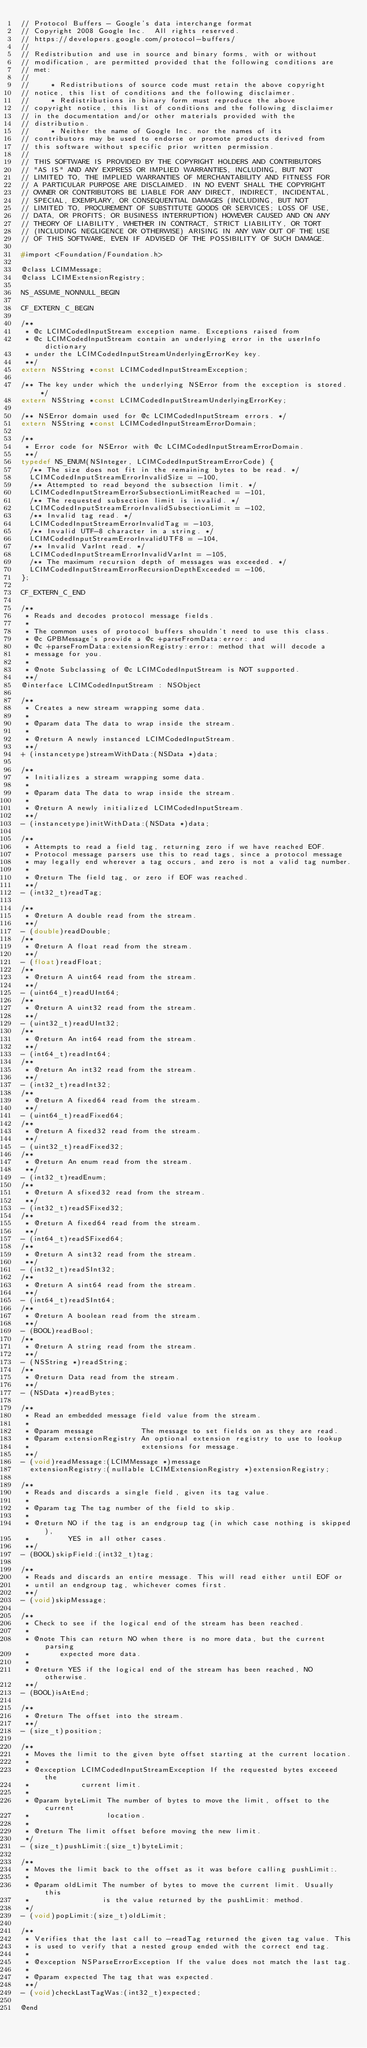<code> <loc_0><loc_0><loc_500><loc_500><_C_>// Protocol Buffers - Google's data interchange format
// Copyright 2008 Google Inc.  All rights reserved.
// https://developers.google.com/protocol-buffers/
//
// Redistribution and use in source and binary forms, with or without
// modification, are permitted provided that the following conditions are
// met:
//
//     * Redistributions of source code must retain the above copyright
// notice, this list of conditions and the following disclaimer.
//     * Redistributions in binary form must reproduce the above
// copyright notice, this list of conditions and the following disclaimer
// in the documentation and/or other materials provided with the
// distribution.
//     * Neither the name of Google Inc. nor the names of its
// contributors may be used to endorse or promote products derived from
// this software without specific prior written permission.
//
// THIS SOFTWARE IS PROVIDED BY THE COPYRIGHT HOLDERS AND CONTRIBUTORS
// "AS IS" AND ANY EXPRESS OR IMPLIED WARRANTIES, INCLUDING, BUT NOT
// LIMITED TO, THE IMPLIED WARRANTIES OF MERCHANTABILITY AND FITNESS FOR
// A PARTICULAR PURPOSE ARE DISCLAIMED. IN NO EVENT SHALL THE COPYRIGHT
// OWNER OR CONTRIBUTORS BE LIABLE FOR ANY DIRECT, INDIRECT, INCIDENTAL,
// SPECIAL, EXEMPLARY, OR CONSEQUENTIAL DAMAGES (INCLUDING, BUT NOT
// LIMITED TO, PROCUREMENT OF SUBSTITUTE GOODS OR SERVICES; LOSS OF USE,
// DATA, OR PROFITS; OR BUSINESS INTERRUPTION) HOWEVER CAUSED AND ON ANY
// THEORY OF LIABILITY, WHETHER IN CONTRACT, STRICT LIABILITY, OR TORT
// (INCLUDING NEGLIGENCE OR OTHERWISE) ARISING IN ANY WAY OUT OF THE USE
// OF THIS SOFTWARE, EVEN IF ADVISED OF THE POSSIBILITY OF SUCH DAMAGE.

#import <Foundation/Foundation.h>

@class LCIMMessage;
@class LCIMExtensionRegistry;

NS_ASSUME_NONNULL_BEGIN

CF_EXTERN_C_BEGIN

/**
 * @c LCIMCodedInputStream exception name. Exceptions raised from
 * @c LCIMCodedInputStream contain an underlying error in the userInfo dictionary
 * under the LCIMCodedInputStreamUnderlyingErrorKey key.
 **/
extern NSString *const LCIMCodedInputStreamException;

/** The key under which the underlying NSError from the exception is stored. */
extern NSString *const LCIMCodedInputStreamUnderlyingErrorKey;

/** NSError domain used for @c LCIMCodedInputStream errors. */
extern NSString *const LCIMCodedInputStreamErrorDomain;

/**
 * Error code for NSError with @c LCIMCodedInputStreamErrorDomain.
 **/
typedef NS_ENUM(NSInteger, LCIMCodedInputStreamErrorCode) {
  /** The size does not fit in the remaining bytes to be read. */
  LCIMCodedInputStreamErrorInvalidSize = -100,
  /** Attempted to read beyond the subsection limit. */
  LCIMCodedInputStreamErrorSubsectionLimitReached = -101,
  /** The requested subsection limit is invalid. */
  LCIMCodedInputStreamErrorInvalidSubsectionLimit = -102,
  /** Invalid tag read. */
  LCIMCodedInputStreamErrorInvalidTag = -103,
  /** Invalid UTF-8 character in a string. */
  LCIMCodedInputStreamErrorInvalidUTF8 = -104,
  /** Invalid VarInt read. */
  LCIMCodedInputStreamErrorInvalidVarInt = -105,
  /** The maximum recursion depth of messages was exceeded. */
  LCIMCodedInputStreamErrorRecursionDepthExceeded = -106,
};

CF_EXTERN_C_END

/**
 * Reads and decodes protocol message fields.
 *
 * The common uses of protocol buffers shouldn't need to use this class.
 * @c GPBMessage's provide a @c +parseFromData:error: and
 * @c +parseFromData:extensionRegistry:error: method that will decode a
 * message for you.
 *
 * @note Subclassing of @c LCIMCodedInputStream is NOT supported.
 **/
@interface LCIMCodedInputStream : NSObject

/**
 * Creates a new stream wrapping some data.
 *
 * @param data The data to wrap inside the stream.
 *
 * @return A newly instanced LCIMCodedInputStream.
 **/
+ (instancetype)streamWithData:(NSData *)data;

/**
 * Initializes a stream wrapping some data.
 *
 * @param data The data to wrap inside the stream.
 *
 * @return A newly initialized LCIMCodedInputStream.
 **/
- (instancetype)initWithData:(NSData *)data;

/**
 * Attempts to read a field tag, returning zero if we have reached EOF.
 * Protocol message parsers use this to read tags, since a protocol message
 * may legally end wherever a tag occurs, and zero is not a valid tag number.
 *
 * @return The field tag, or zero if EOF was reached.
 **/
- (int32_t)readTag;

/**
 * @return A double read from the stream.
 **/
- (double)readDouble;
/**
 * @return A float read from the stream.
 **/
- (float)readFloat;
/**
 * @return A uint64 read from the stream.
 **/
- (uint64_t)readUInt64;
/**
 * @return A uint32 read from the stream.
 **/
- (uint32_t)readUInt32;
/**
 * @return An int64 read from the stream.
 **/
- (int64_t)readInt64;
/**
 * @return An int32 read from the stream.
 **/
- (int32_t)readInt32;
/**
 * @return A fixed64 read from the stream.
 **/
- (uint64_t)readFixed64;
/**
 * @return A fixed32 read from the stream.
 **/
- (uint32_t)readFixed32;
/**
 * @return An enum read from the stream.
 **/
- (int32_t)readEnum;
/**
 * @return A sfixed32 read from the stream.
 **/
- (int32_t)readSFixed32;
/**
 * @return A fixed64 read from the stream.
 **/
- (int64_t)readSFixed64;
/**
 * @return A sint32 read from the stream.
 **/
- (int32_t)readSInt32;
/**
 * @return A sint64 read from the stream.
 **/
- (int64_t)readSInt64;
/**
 * @return A boolean read from the stream.
 **/
- (BOOL)readBool;
/**
 * @return A string read from the stream.
 **/
- (NSString *)readString;
/**
 * @return Data read from the stream.
 **/
- (NSData *)readBytes;

/**
 * Read an embedded message field value from the stream.
 *
 * @param message           The message to set fields on as they are read.
 * @param extensionRegistry An optional extension registry to use to lookup
 *                          extensions for message.
 **/
- (void)readMessage:(LCIMMessage *)message
  extensionRegistry:(nullable LCIMExtensionRegistry *)extensionRegistry;

/**
 * Reads and discards a single field, given its tag value.
 *
 * @param tag The tag number of the field to skip.
 *
 * @return NO if the tag is an endgroup tag (in which case nothing is skipped),
 *         YES in all other cases.
 **/
- (BOOL)skipField:(int32_t)tag;

/**
 * Reads and discards an entire message. This will read either until EOF or
 * until an endgroup tag, whichever comes first.
 **/
- (void)skipMessage;

/**
 * Check to see if the logical end of the stream has been reached.
 *
 * @note This can return NO when there is no more data, but the current parsing
 *       expected more data.
 *
 * @return YES if the logical end of the stream has been reached, NO otherwise.
 **/
- (BOOL)isAtEnd;

/**
 * @return The offset into the stream.
 **/
- (size_t)position;

/**
 * Moves the limit to the given byte offset starting at the current location.
 *
 * @exception LCIMCodedInputStreamException If the requested bytes exceeed the
 *            current limit.
 *
 * @param byteLimit The number of bytes to move the limit, offset to the current
 *                  location.
 *
 * @return The limit offset before moving the new limit.
 */
- (size_t)pushLimit:(size_t)byteLimit;

/**
 * Moves the limit back to the offset as it was before calling pushLimit:.
 *
 * @param oldLimit The number of bytes to move the current limit. Usually this
 *                 is the value returned by the pushLimit: method.
 */
- (void)popLimit:(size_t)oldLimit;

/**
 * Verifies that the last call to -readTag returned the given tag value. This
 * is used to verify that a nested group ended with the correct end tag.
 *
 * @exception NSParseErrorException If the value does not match the last tag.
 *
 * @param expected The tag that was expected.
 **/
- (void)checkLastTagWas:(int32_t)expected;

@end
</code> 